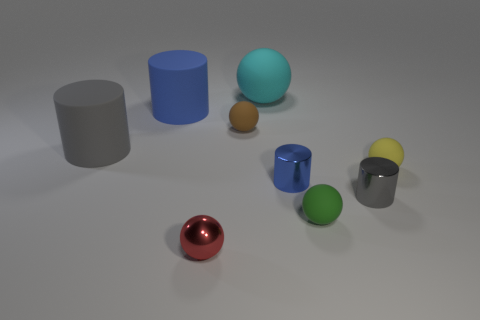There is a large thing that is both behind the gray matte cylinder and in front of the cyan object; what shape is it?
Keep it short and to the point. Cylinder. How many other objects are there of the same color as the metal ball?
Offer a very short reply. 0. What shape is the large blue object?
Provide a short and direct response. Cylinder. What is the color of the object right of the gray cylinder that is on the right side of the blue rubber object?
Give a very brief answer. Yellow. Do the tiny metallic ball and the object behind the blue matte cylinder have the same color?
Offer a terse response. No. What is the tiny thing that is left of the small yellow sphere and to the right of the green sphere made of?
Offer a very short reply. Metal. Are there any yellow things that have the same size as the blue rubber thing?
Your answer should be compact. No. There is a gray object that is the same size as the brown ball; what is it made of?
Make the answer very short. Metal. There is a big blue thing; what number of small metal cylinders are in front of it?
Provide a succinct answer. 2. There is a small matte thing that is behind the yellow thing; does it have the same shape as the tiny red metallic object?
Your answer should be compact. Yes. 